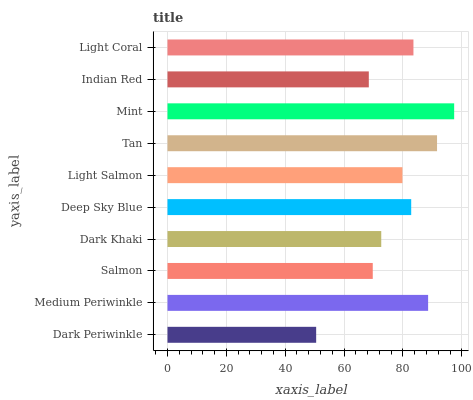Is Dark Periwinkle the minimum?
Answer yes or no. Yes. Is Mint the maximum?
Answer yes or no. Yes. Is Medium Periwinkle the minimum?
Answer yes or no. No. Is Medium Periwinkle the maximum?
Answer yes or no. No. Is Medium Periwinkle greater than Dark Periwinkle?
Answer yes or no. Yes. Is Dark Periwinkle less than Medium Periwinkle?
Answer yes or no. Yes. Is Dark Periwinkle greater than Medium Periwinkle?
Answer yes or no. No. Is Medium Periwinkle less than Dark Periwinkle?
Answer yes or no. No. Is Deep Sky Blue the high median?
Answer yes or no. Yes. Is Light Salmon the low median?
Answer yes or no. Yes. Is Mint the high median?
Answer yes or no. No. Is Light Coral the low median?
Answer yes or no. No. 